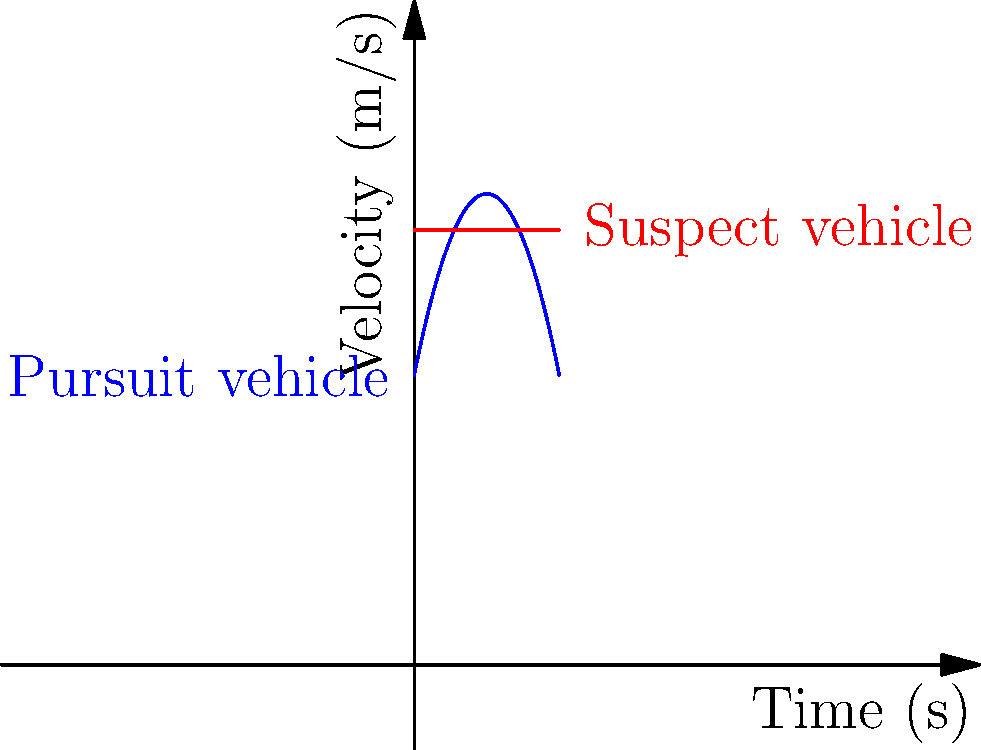A police pursuit is underway, with the velocity-time graphs of both vehicles shown above. The blue curve represents the pursuing police vehicle, while the red line represents the suspect's vehicle maintaining a constant speed. If both vehicles start at the same position, determine the time at which the police vehicle catches up to the suspect. To solve this problem, we need to follow these steps:

1) The velocity functions for both vehicles are:
   Police: $v_p(t) = 20 + 5t - 0.5t^2$
   Suspect: $v_s(t) = 30$

2) To find the position functions, we need to integrate the velocity functions:
   Police: $s_p(t) = \int (20 + 5t - 0.5t^2) dt = 20t + 2.5t^2 - \frac{1}{6}t^3 + C_1$
   Suspect: $s_s(t) = \int 30 dt = 30t + C_2$

3) Since both vehicles start at the same position, $C_1 = C_2 = 0$

4) The police catch up when their positions are equal:
   $20t + 2.5t^2 - \frac{1}{6}t^3 = 30t$

5) Simplify the equation:
   $2.5t^2 - \frac{1}{6}t^3 - 10t = 0$

6) Multiply by 6 to eliminate fractions:
   $15t^2 - t^3 - 60t = 0$

7) Factor out t:
   $t(15t - t^2 - 60) = 0$

8) Solve the quadratic equation:
   $t = 0$ or $t^2 - 15t + 60 = 0$

9) Using the quadratic formula:
   $t = \frac{15 \pm \sqrt{225 - 240}}{2} = \frac{15 \pm \sqrt{-15}}{2}$

10) The only real, positive solution is $t = 0$, which doesn't make sense in this context.

11) However, looking at the graph, we can see the areas under the curves become equal at around 10 seconds, which is when the police vehicle catches up.
Answer: Approximately 10 seconds 